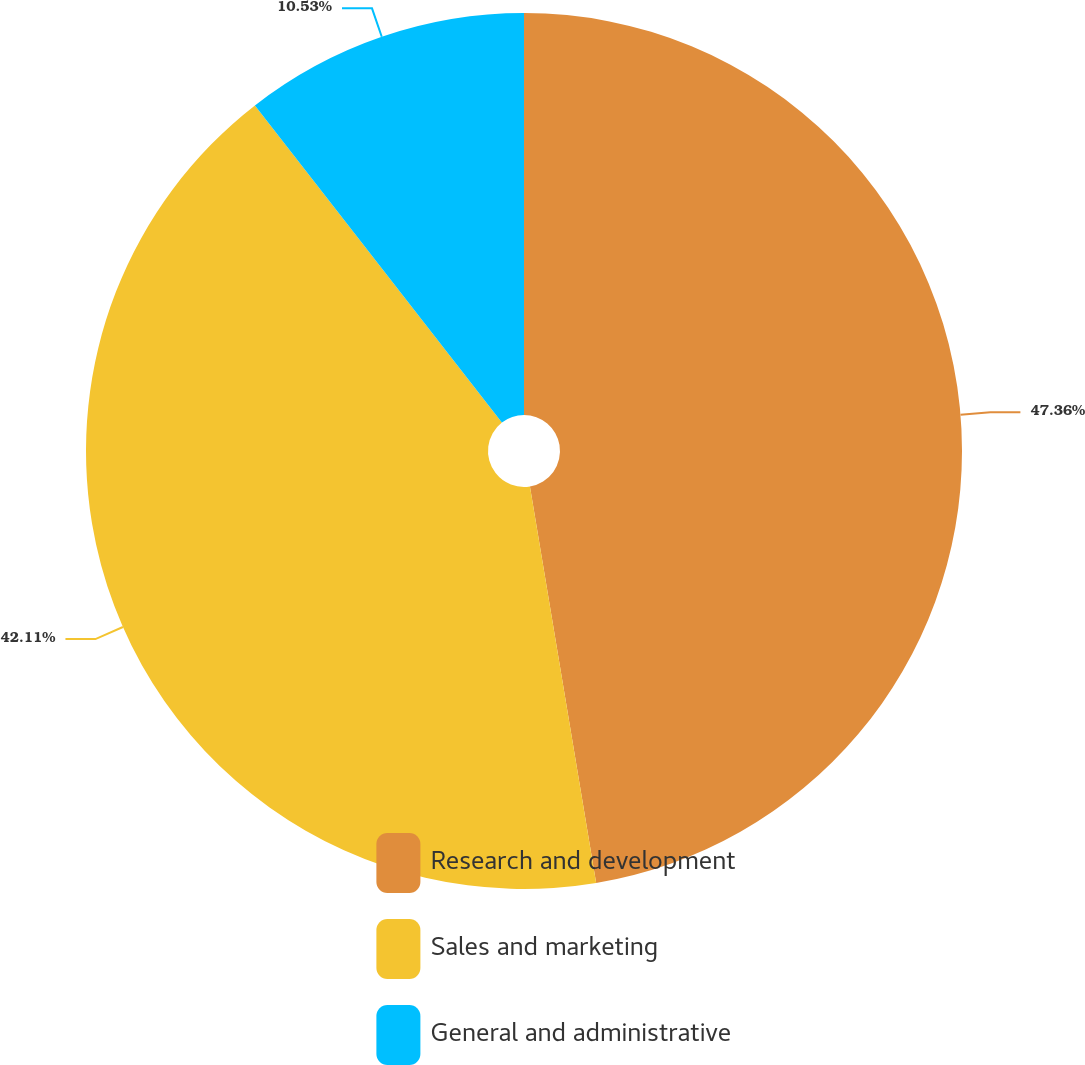Convert chart. <chart><loc_0><loc_0><loc_500><loc_500><pie_chart><fcel>Research and development<fcel>Sales and marketing<fcel>General and administrative<nl><fcel>47.37%<fcel>42.11%<fcel>10.53%<nl></chart> 